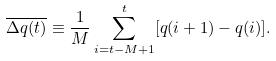<formula> <loc_0><loc_0><loc_500><loc_500>\overline { \Delta q ( t ) } \equiv \frac { 1 } { M } \sum _ { i = t - M + 1 } ^ { t } [ q ( i + 1 ) - q ( i ) ] .</formula> 